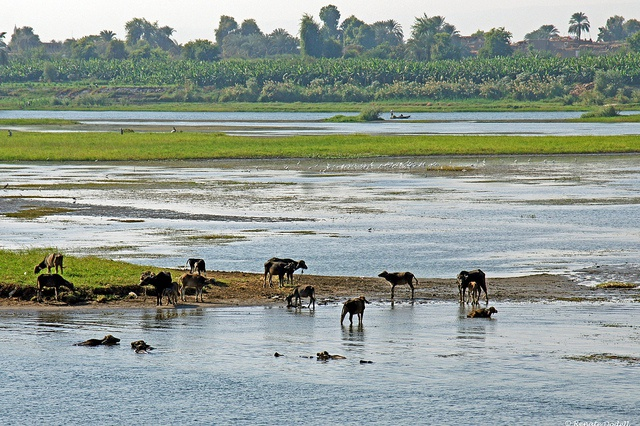Describe the objects in this image and their specific colors. I can see cow in white, black, gray, and darkgray tones, cow in white, black, lightgray, gray, and darkgray tones, cow in white, black, and gray tones, cow in white, black, darkgreen, gray, and maroon tones, and cow in white, black, gray, and tan tones in this image. 